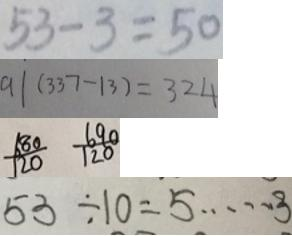Convert formula to latex. <formula><loc_0><loc_0><loc_500><loc_500>5 3 - 3 = 5 0 
 9 1 ( 3 3 7 - 1 3 ) = 3 2 4 
 \frac { 6 8 0 } { 1 2 0 } \frac { 6 9 0 } { 1 2 0 } 
 5 3 \div 1 0 = 5 \cdots 3</formula> 